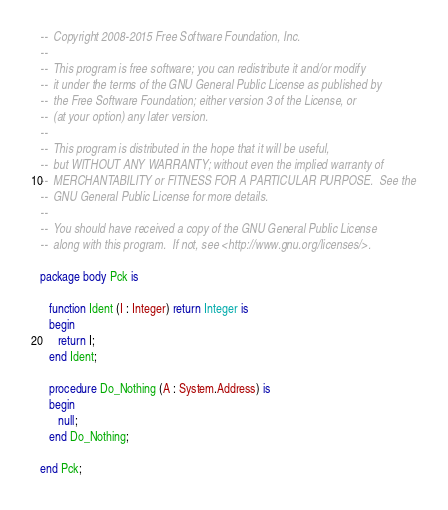Convert code to text. <code><loc_0><loc_0><loc_500><loc_500><_Ada_>--  Copyright 2008-2015 Free Software Foundation, Inc.
--
--  This program is free software; you can redistribute it and/or modify
--  it under the terms of the GNU General Public License as published by
--  the Free Software Foundation; either version 3 of the License, or
--  (at your option) any later version.
--
--  This program is distributed in the hope that it will be useful,
--  but WITHOUT ANY WARRANTY; without even the implied warranty of
--  MERCHANTABILITY or FITNESS FOR A PARTICULAR PURPOSE.  See the
--  GNU General Public License for more details.
--
--  You should have received a copy of the GNU General Public License
--  along with this program.  If not, see <http://www.gnu.org/licenses/>.

package body Pck is

   function Ident (I : Integer) return Integer is
   begin
      return I;
   end Ident;

   procedure Do_Nothing (A : System.Address) is
   begin
      null;
   end Do_Nothing;

end Pck;
</code> 